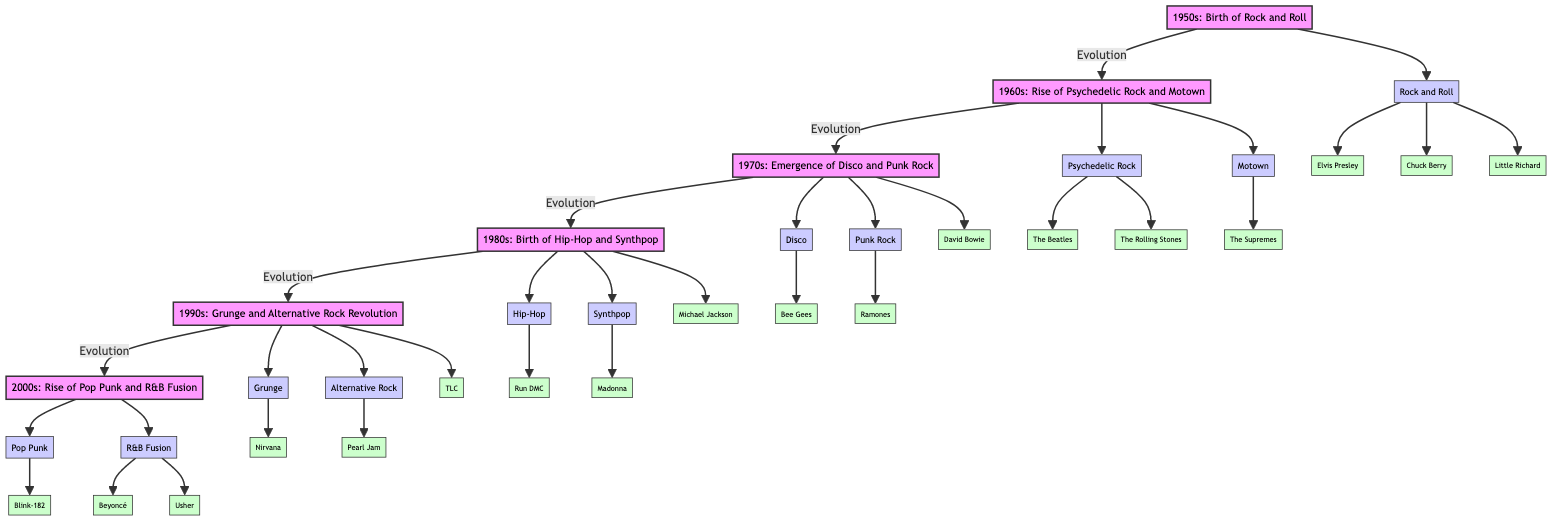What genre emerged in the 1950s? According to the diagram, the genre that emerged in the 1950s is Rock and Roll. This is depicted as the genre linked directly to the 1950s node.
Answer: Rock and Roll How many key artists are associated with the 1960s? The diagram shows that the 1960s node connects to three key artists through the Psychedelic Rock genre and one key artist through the Motown genre. Thus, there are a total of four key artists listed under this decade.
Answer: 4 Which genre is directly linked to the 1980s? The diagram indicates two genres directly linked to the 1980s, which are Hip-Hop and Synthpop. Both are connected to the 1980s node, showcasing the music styles of this decade.
Answer: Hip-Hop and Synthpop What was the main influence from the 1970s to the 1980s? The flow in the diagram indicates that the 1970s genre node (Disco and Punk Rock) leads to the 1980s genre node. Hence, Disco and Punk Rock serve as the main influences transitioning into the music styles of the 1980s.
Answer: Disco and Punk Rock Which artist is associated with the genre Disco from the 1970s? The diagram identifies the Bee Gees as the artist associated with the Disco genre within the 1970s section. This connection directly links the Bee Gees to the Disco genre node.
Answer: Bee Gees What decade did the Grunge genre gain significance? The diagram clearly shows that the Grunge genre is linked to the 1990s node. Therefore, it suggests that Grunge gained prominence during this decade.
Answer: 1990s Which two genres are linked to the 2000s? The diagram indicates that the 2000s node connects to the genres Pop Punk and R&B Fusion. This representation illustrates the music styles prominent in the 2000s.
Answer: Pop Punk and R&B Fusion How many decades are represented in the diagram? By counting the decade nodes in the diagram, there are a total of six decades represented from the 1950s to the 2000s. This includes each decade node shown in sequence.
Answer: 6 Which artist represents the R&B Fusion genre in the 2000s? The diagram specifies that both Beyoncé and Usher are artists linked to the R&B Fusion genre within the 2000s.
Answer: Beyoncé and Usher 